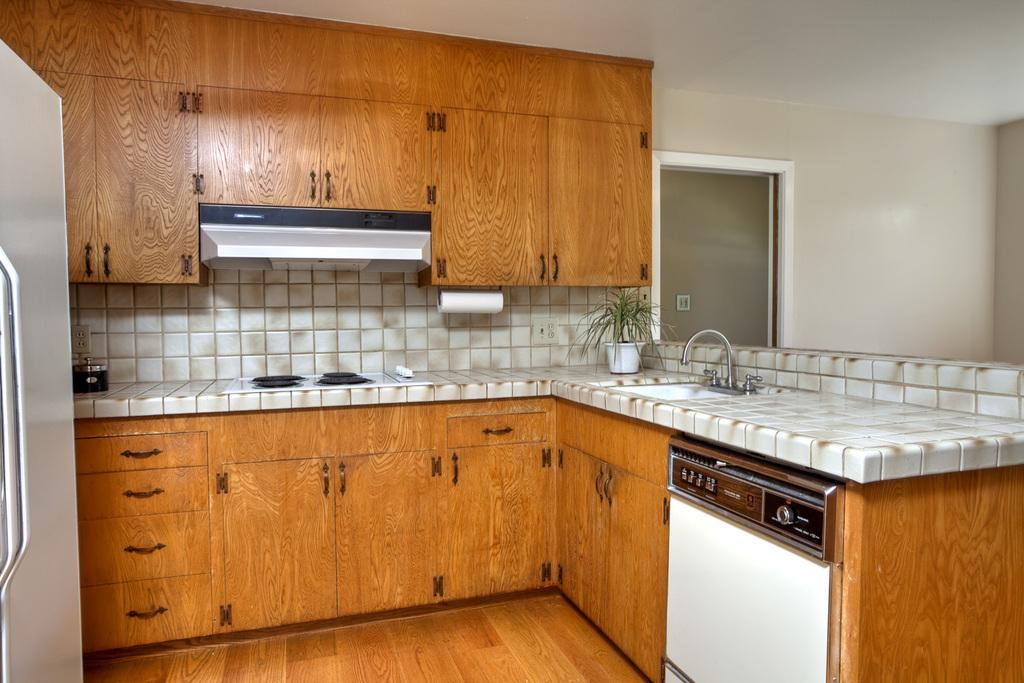What type of surface is visible in the image? There is a floor in the image. What type of plant can be seen in the image? There is a houseplant in the image. What can be used for water in the image? There is a tap and a sink in the image. What can be used for cooking in the image? There is a stove in the image. What can be used for cleaning or wiping in the image? There is a tissue paper roll in the image. What can be used for holding liquids in the image? There is a bowl with a lid and a cup in the image. What can be used for storage in the image? There are cupboards in the image. What can be seen in the background of the image? The walls are visible in the background of the image. What type of coil is present in the image? There is no coil present in the image. How does the lock on the cupboard work in the image? There is no lock on the cupboard in the image. What is the taste of the water coming from the tap in the image? The taste of the water cannot be determined from the image alone. 